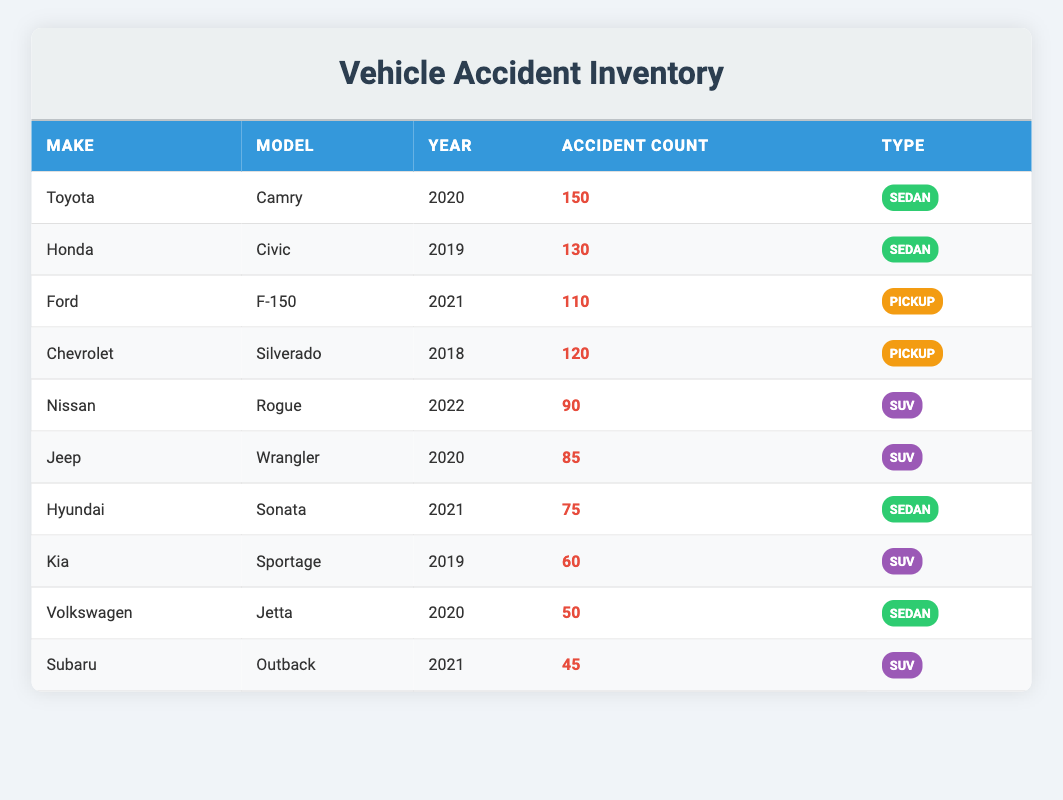What is the make and model of the vehicle with the highest accident count? By examining the table, the vehicle with the highest accident count is listed as Toyota Camry with 150 accidents.
Answer: Toyota Camry Which vehicle type has the lowest accident count? Looking through the table, the vehicle type with the lowest accident count is the Subaru Outback, which has 45 accidents.
Answer: SUV How many total accidents are recorded for all vehicles listed in the table? To find the total accidents, we sum the accident counts: 150 + 130 + 110 + 120 + 90 + 85 + 75 + 60 + 50 + 45 = 1020 total accidents.
Answer: 1020 Are there more sedans or SUVs listed in the table? The table lists 5 sedans (Toyota Camry, Honda Civic, Hyundai Sonata, Volkswagen Jetta) and 4 SUVs (Nissan Rogue, Jeep Wrangler, Kia Sportage, Subaru Outback). So, there are more sedans than SUVs.
Answer: Yes What is the average accident count for pickup trucks? The only two pickup trucks in the table are the Ford F-150 with 110 accidents and the Chevrolet Silverado with 120 accidents. The average is calculated as (110 + 120) / 2 = 115.
Answer: 115 Which vehicle model has the highest number of accidents among the SUVs? The Nissan Rogue has the highest number of accidents among the SUVs listed, with 90 accidents compared to Jeep Wrangler's 85, Kia Sportage's 60, and Subaru Outback's 45.
Answer: Nissan Rogue How many years separate the newest and oldest vehicles in the table? The newest vehicle is the Nissan Rogue from 2022, and the oldest is the Chevrolet Silverado from 2018. Therefore, the difference in years is 2022 - 2018 = 4 years.
Answer: 4 Is there a vehicle make that has two different models categorized under the same type? Upon reviewing the table, there is no vehicle make with two different models listed under the same type; each vehicle make has a single model and type.
Answer: No 